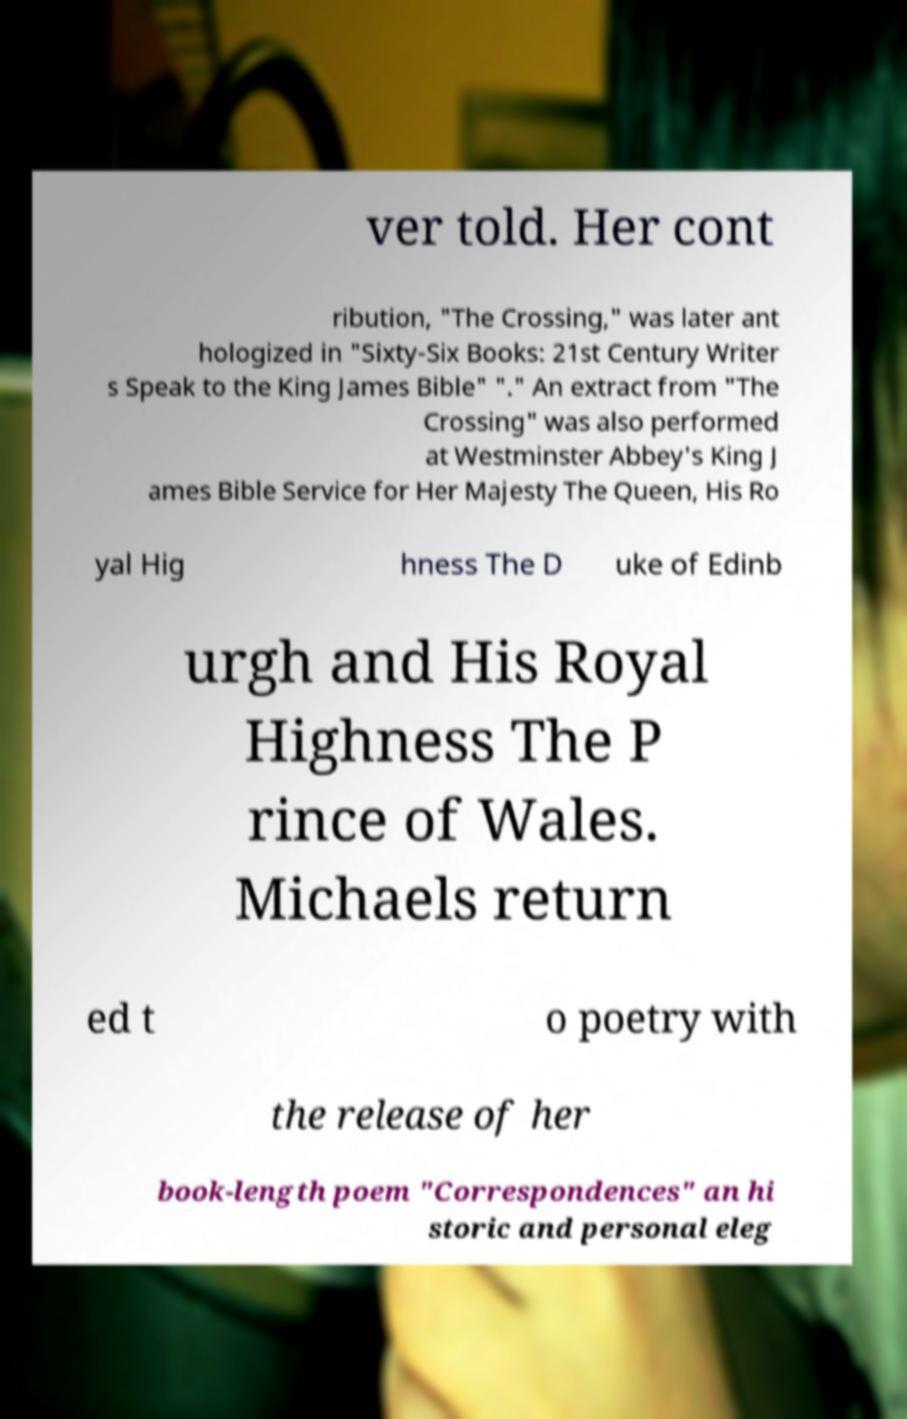I need the written content from this picture converted into text. Can you do that? ver told. Her cont ribution, "The Crossing," was later ant hologized in "Sixty-Six Books: 21st Century Writer s Speak to the King James Bible" "." An extract from "The Crossing" was also performed at Westminster Abbey's King J ames Bible Service for Her Majesty The Queen, His Ro yal Hig hness The D uke of Edinb urgh and His Royal Highness The P rince of Wales. Michaels return ed t o poetry with the release of her book-length poem "Correspondences" an hi storic and personal eleg 